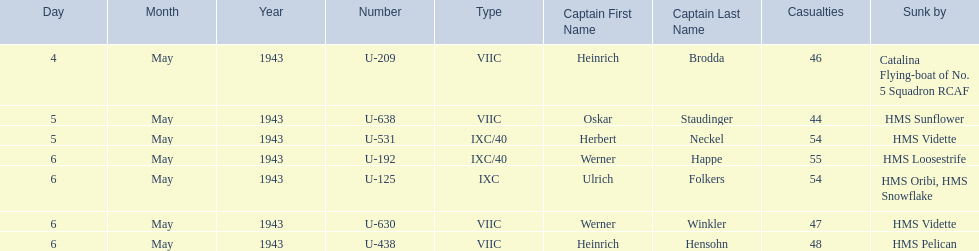What was the number of casualties on may 4 1943? 46. 